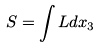<formula> <loc_0><loc_0><loc_500><loc_500>S = \int L d x _ { 3 }</formula> 